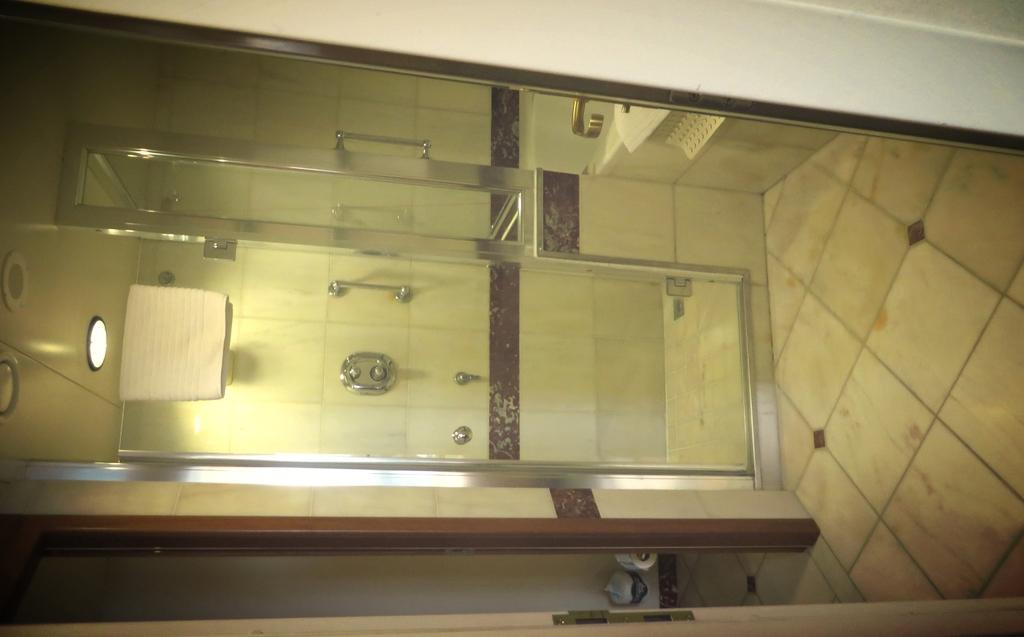What is one of the main features of the image? There is a door in the image. What is beneath the door in the image? There is a floor in the image. What can be seen on a shelf in the image? There are objects on a shelf in the image. What type of room is depicted in the image? The image contains a bathroom. What is the glass element in the image used for? The glass element in the image is a glass door. What can be seen through the glass door? A wall is visible through the glass. What is used for controlling the flow of water in the image? Taps are present in the image. What is used for opening and closing doors or drawers in the image? Handles are visible in the image. What is used for providing light in the image? Lights are present in the image. What is hanging on the glass door in the image? There is a towel on the glass door. What type of brick is used to build the point in the image? There is no brick or point present in the image. 